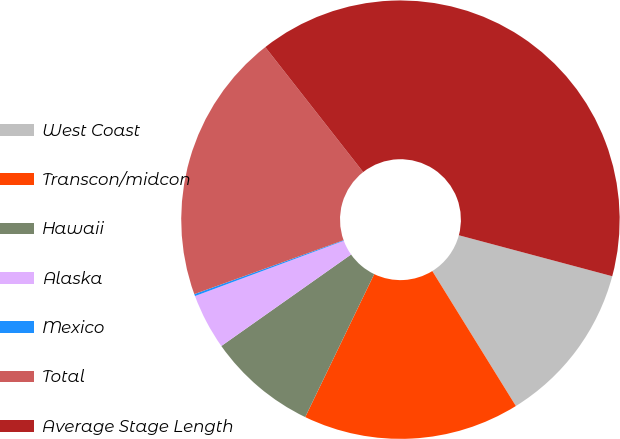Convert chart. <chart><loc_0><loc_0><loc_500><loc_500><pie_chart><fcel>West Coast<fcel>Transcon/midcon<fcel>Hawaii<fcel>Alaska<fcel>Mexico<fcel>Total<fcel>Average Stage Length<nl><fcel>12.02%<fcel>15.98%<fcel>8.07%<fcel>4.11%<fcel>0.15%<fcel>19.94%<fcel>39.73%<nl></chart> 